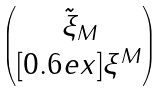<formula> <loc_0><loc_0><loc_500><loc_500>\begin{pmatrix} \, \tilde { \xi } _ { M } \, \\ [ 0 . 6 e x ] { \xi ^ { M } } \end{pmatrix}</formula> 